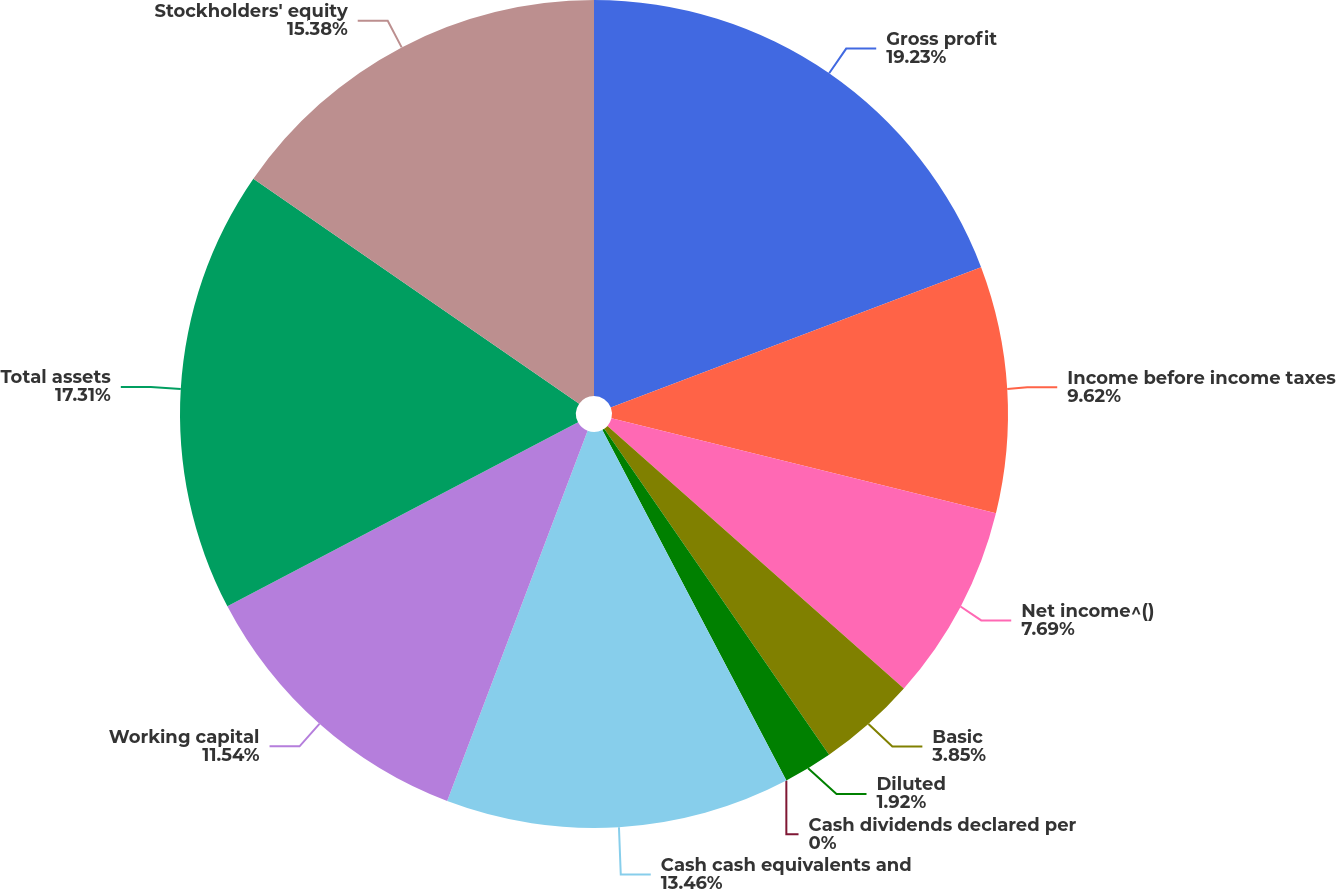Convert chart. <chart><loc_0><loc_0><loc_500><loc_500><pie_chart><fcel>Gross profit<fcel>Income before income taxes<fcel>Net income^()<fcel>Basic<fcel>Diluted<fcel>Cash dividends declared per<fcel>Cash cash equivalents and<fcel>Working capital<fcel>Total assets<fcel>Stockholders' equity<nl><fcel>19.23%<fcel>9.62%<fcel>7.69%<fcel>3.85%<fcel>1.92%<fcel>0.0%<fcel>13.46%<fcel>11.54%<fcel>17.31%<fcel>15.38%<nl></chart> 